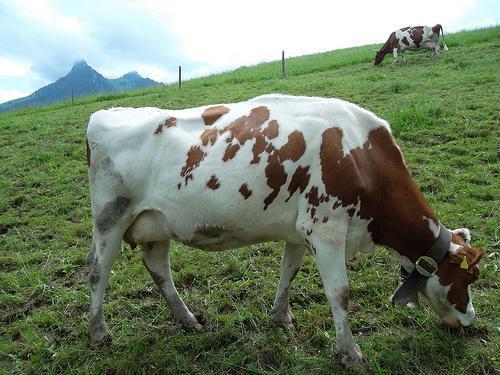How many fence poles do you see in the picture?
Give a very brief answer. 3. How many cows are in the picture?
Give a very brief answer. 2. How many cows are shown?
Give a very brief answer. 2. How many legs does the cow have?
Give a very brief answer. 4. 